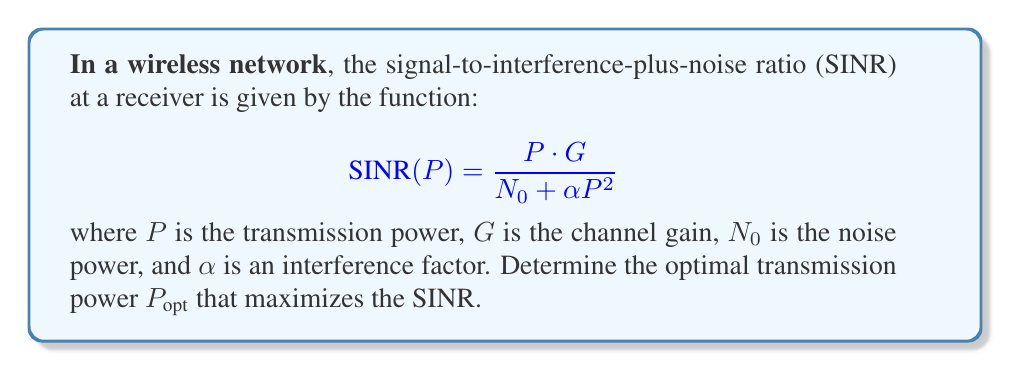Give your solution to this math problem. To find the optimal transmission power, we need to maximize the SINR function. This can be done by finding the derivative of SINR with respect to P and setting it to zero.

Step 1: Calculate the derivative of SINR with respect to P using the quotient rule.
$$\frac{d}{dP}SINR(P) = \frac{(N_0 + \alpha P^2) \cdot G - P \cdot G \cdot (2\alpha P)}{(N_0 + \alpha P^2)^2}$$

Step 2: Simplify the numerator.
$$\frac{d}{dP}SINR(P) = \frac{N_0G + \alpha P^2G - 2\alpha P^2G}{(N_0 + \alpha P^2)^2} = \frac{N_0G - \alpha P^2G}{(N_0 + \alpha P^2)^2}$$

Step 3: Set the derivative equal to zero and solve for P.
$$\frac{N_0G - \alpha P^2G}{(N_0 + \alpha P^2)^2} = 0$$

$$N_0G - \alpha P^2G = 0$$

$$N_0 = \alpha P^2$$

$$P_{opt} = \sqrt{\frac{N_0}{\alpha}}$$

Step 4: Verify that this critical point is a maximum by checking the second derivative (which should be negative at this point).
Answer: $P_{opt} = \sqrt{\frac{N_0}{\alpha}}$ 